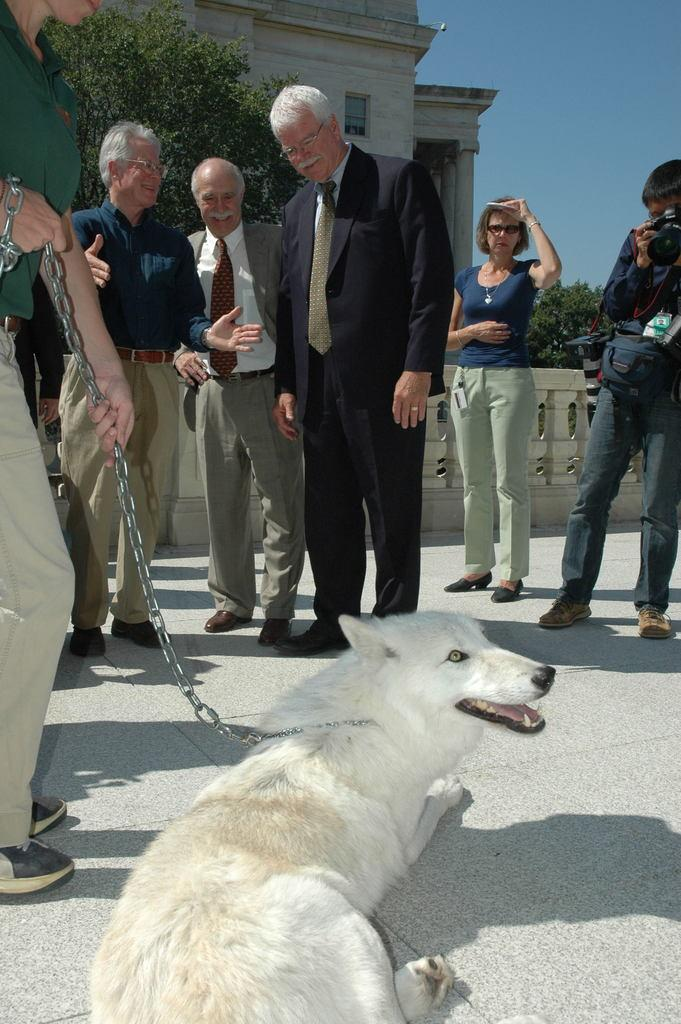What can be seen in the image? There are people standing in the image, along with a dog. What is visible in the background of the image? There is a tree, a building, and the sky visible in the background of the image. How many people are expressing anger in the image? There is no indication of anger in the image; the people's expressions are not described. 